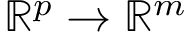Convert formula to latex. <formula><loc_0><loc_0><loc_500><loc_500>\mathbb { R } ^ { p } \to \mathbb { R } ^ { m }</formula> 